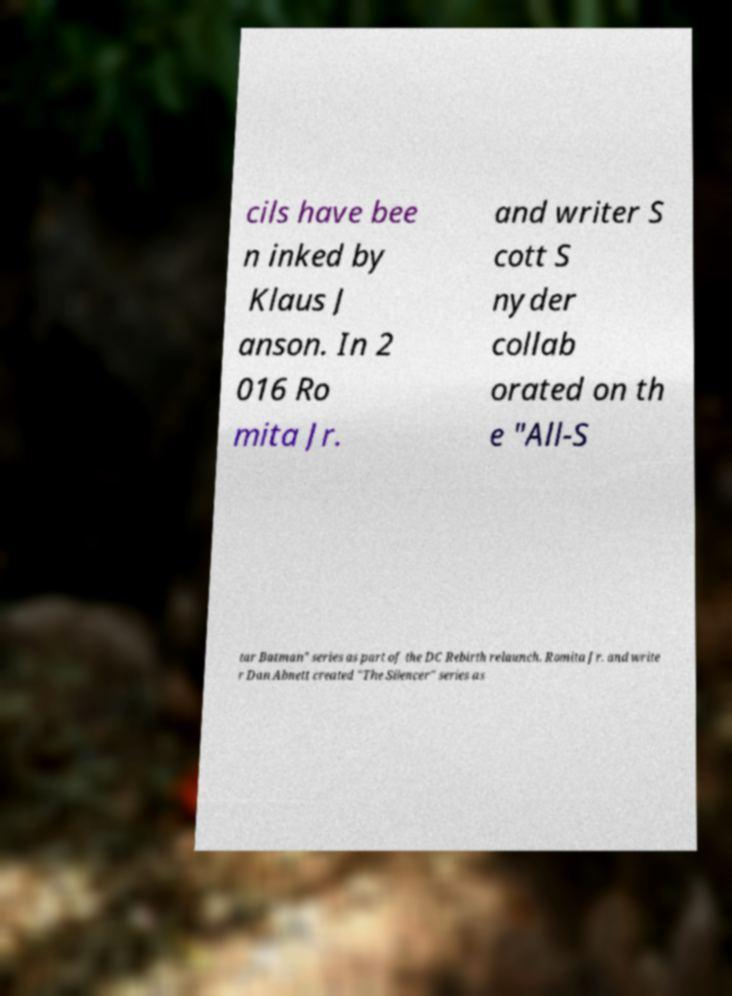What messages or text are displayed in this image? I need them in a readable, typed format. cils have bee n inked by Klaus J anson. In 2 016 Ro mita Jr. and writer S cott S nyder collab orated on th e "All-S tar Batman" series as part of the DC Rebirth relaunch. Romita Jr. and write r Dan Abnett created "The Silencer" series as 